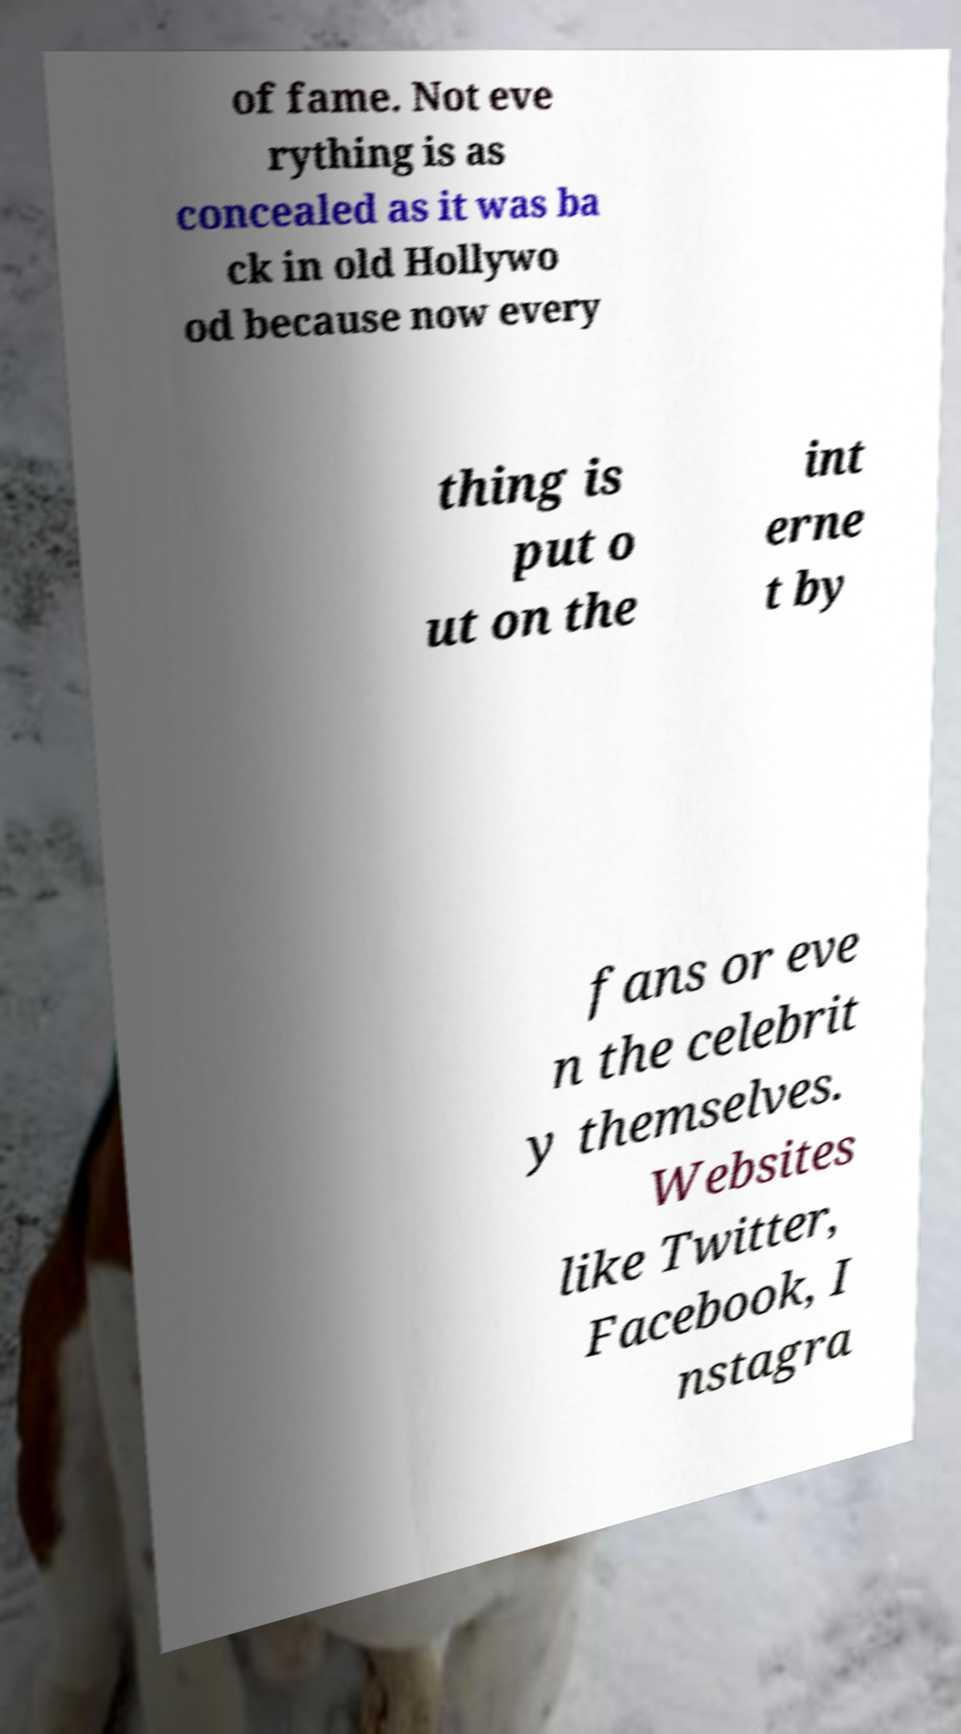Could you assist in decoding the text presented in this image and type it out clearly? of fame. Not eve rything is as concealed as it was ba ck in old Hollywo od because now every thing is put o ut on the int erne t by fans or eve n the celebrit y themselves. Websites like Twitter, Facebook, I nstagra 